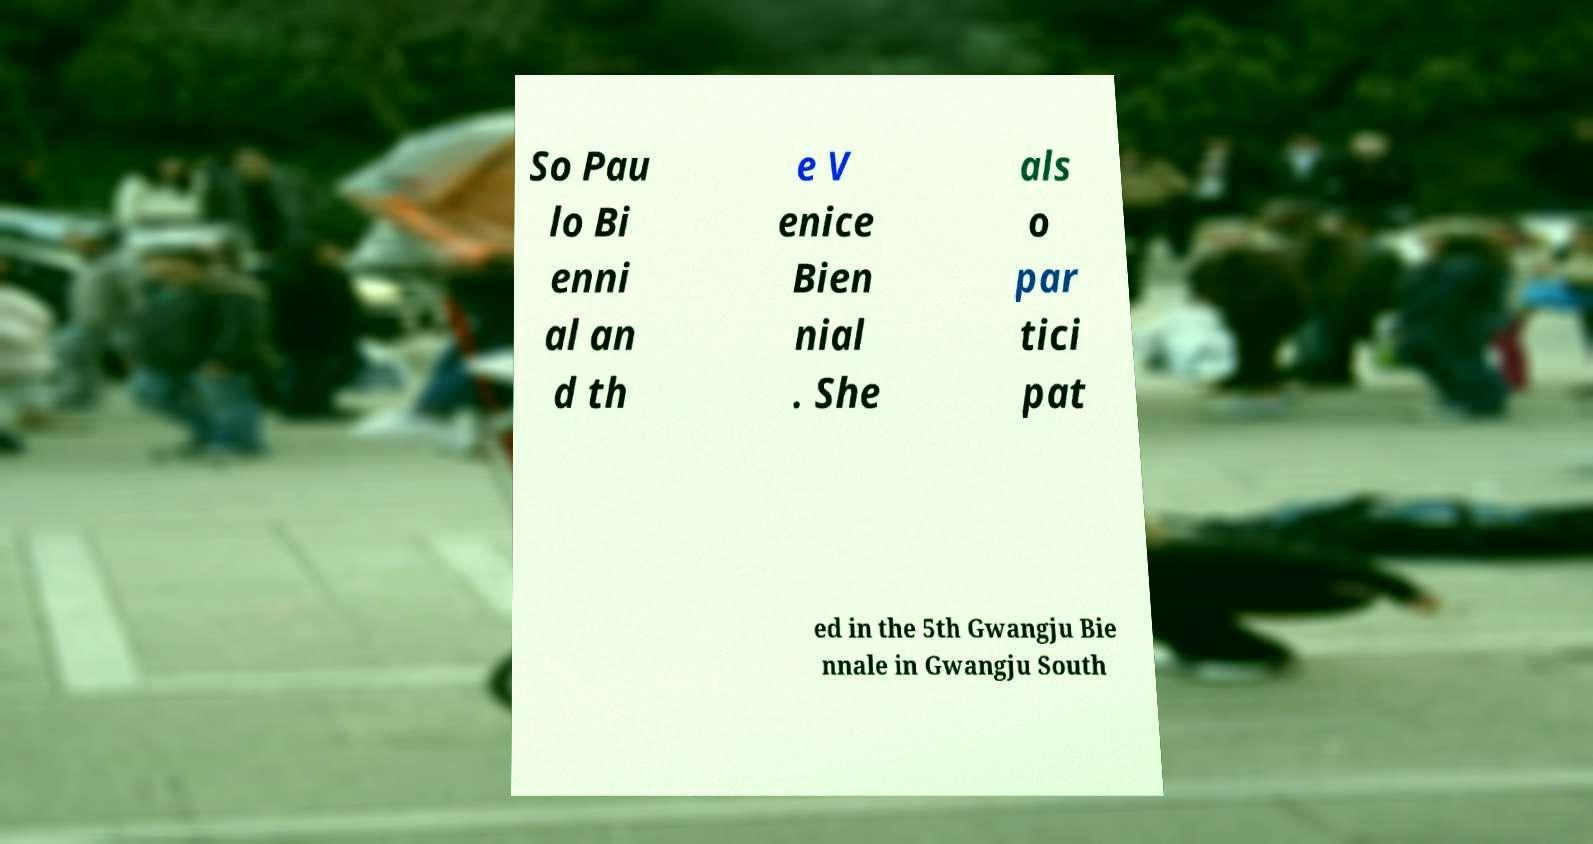There's text embedded in this image that I need extracted. Can you transcribe it verbatim? So Pau lo Bi enni al an d th e V enice Bien nial . She als o par tici pat ed in the 5th Gwangju Bie nnale in Gwangju South 